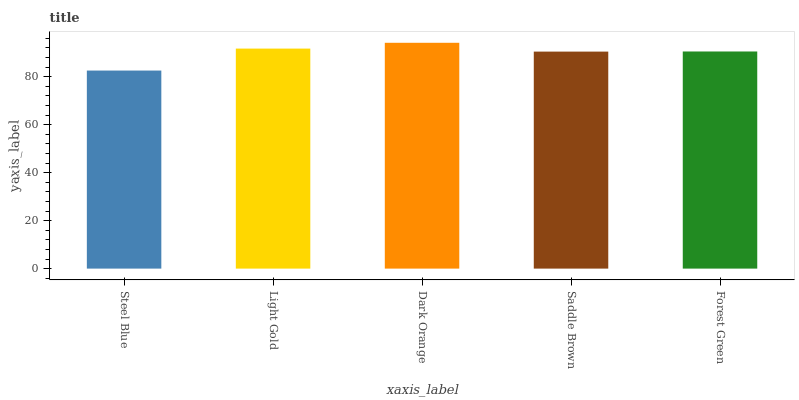Is Steel Blue the minimum?
Answer yes or no. Yes. Is Dark Orange the maximum?
Answer yes or no. Yes. Is Light Gold the minimum?
Answer yes or no. No. Is Light Gold the maximum?
Answer yes or no. No. Is Light Gold greater than Steel Blue?
Answer yes or no. Yes. Is Steel Blue less than Light Gold?
Answer yes or no. Yes. Is Steel Blue greater than Light Gold?
Answer yes or no. No. Is Light Gold less than Steel Blue?
Answer yes or no. No. Is Forest Green the high median?
Answer yes or no. Yes. Is Forest Green the low median?
Answer yes or no. Yes. Is Light Gold the high median?
Answer yes or no. No. Is Dark Orange the low median?
Answer yes or no. No. 